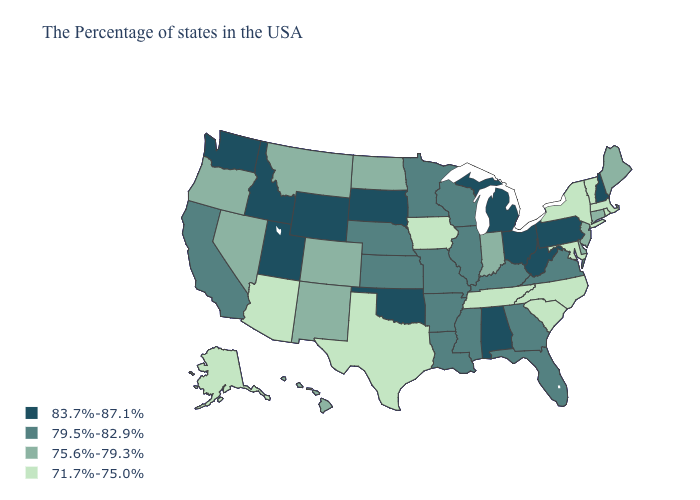Is the legend a continuous bar?
Write a very short answer. No. What is the lowest value in states that border Delaware?
Keep it brief. 71.7%-75.0%. Which states have the lowest value in the USA?
Write a very short answer. Massachusetts, Rhode Island, Vermont, New York, Maryland, North Carolina, South Carolina, Tennessee, Iowa, Texas, Arizona, Alaska. What is the lowest value in the Northeast?
Keep it brief. 71.7%-75.0%. What is the value of Wyoming?
Answer briefly. 83.7%-87.1%. What is the value of Missouri?
Answer briefly. 79.5%-82.9%. Does New Mexico have the highest value in the USA?
Answer briefly. No. What is the value of Kentucky?
Give a very brief answer. 79.5%-82.9%. Name the states that have a value in the range 71.7%-75.0%?
Keep it brief. Massachusetts, Rhode Island, Vermont, New York, Maryland, North Carolina, South Carolina, Tennessee, Iowa, Texas, Arizona, Alaska. What is the lowest value in the MidWest?
Give a very brief answer. 71.7%-75.0%. Name the states that have a value in the range 79.5%-82.9%?
Give a very brief answer. Virginia, Florida, Georgia, Kentucky, Wisconsin, Illinois, Mississippi, Louisiana, Missouri, Arkansas, Minnesota, Kansas, Nebraska, California. Which states have the highest value in the USA?
Answer briefly. New Hampshire, Pennsylvania, West Virginia, Ohio, Michigan, Alabama, Oklahoma, South Dakota, Wyoming, Utah, Idaho, Washington. Name the states that have a value in the range 79.5%-82.9%?
Answer briefly. Virginia, Florida, Georgia, Kentucky, Wisconsin, Illinois, Mississippi, Louisiana, Missouri, Arkansas, Minnesota, Kansas, Nebraska, California. Among the states that border Massachusetts , which have the highest value?
Be succinct. New Hampshire. What is the lowest value in states that border South Dakota?
Be succinct. 71.7%-75.0%. 